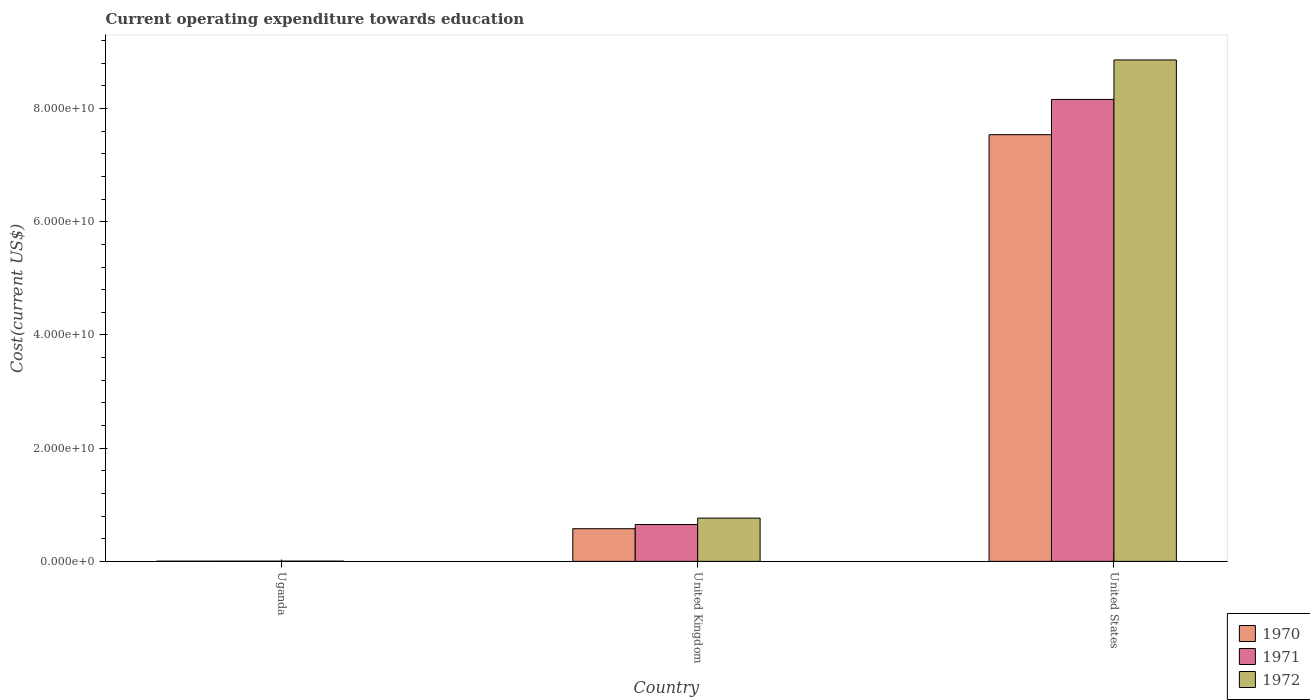How many different coloured bars are there?
Ensure brevity in your answer.  3. Are the number of bars per tick equal to the number of legend labels?
Ensure brevity in your answer.  Yes. Are the number of bars on each tick of the X-axis equal?
Offer a terse response. Yes. How many bars are there on the 2nd tick from the right?
Your response must be concise. 3. What is the label of the 2nd group of bars from the left?
Offer a terse response. United Kingdom. What is the expenditure towards education in 1970 in United States?
Give a very brief answer. 7.54e+1. Across all countries, what is the maximum expenditure towards education in 1972?
Keep it short and to the point. 8.86e+1. Across all countries, what is the minimum expenditure towards education in 1972?
Your answer should be compact. 4.35e+07. In which country was the expenditure towards education in 1970 minimum?
Offer a very short reply. Uganda. What is the total expenditure towards education in 1971 in the graph?
Your answer should be compact. 8.82e+1. What is the difference between the expenditure towards education in 1970 in United Kingdom and that in United States?
Ensure brevity in your answer.  -6.96e+1. What is the difference between the expenditure towards education in 1971 in United States and the expenditure towards education in 1970 in Uganda?
Give a very brief answer. 8.16e+1. What is the average expenditure towards education in 1971 per country?
Your answer should be very brief. 2.94e+1. What is the difference between the expenditure towards education of/in 1970 and expenditure towards education of/in 1971 in United Kingdom?
Your response must be concise. -7.43e+08. What is the ratio of the expenditure towards education in 1972 in Uganda to that in United States?
Make the answer very short. 0. Is the difference between the expenditure towards education in 1970 in United Kingdom and United States greater than the difference between the expenditure towards education in 1971 in United Kingdom and United States?
Offer a very short reply. Yes. What is the difference between the highest and the second highest expenditure towards education in 1971?
Give a very brief answer. 7.51e+1. What is the difference between the highest and the lowest expenditure towards education in 1972?
Your answer should be compact. 8.85e+1. What does the 1st bar from the left in Uganda represents?
Your answer should be very brief. 1970. How many bars are there?
Ensure brevity in your answer.  9. Are all the bars in the graph horizontal?
Your answer should be compact. No. How many countries are there in the graph?
Keep it short and to the point. 3. What is the difference between two consecutive major ticks on the Y-axis?
Your answer should be very brief. 2.00e+1. Does the graph contain any zero values?
Your answer should be very brief. No. Where does the legend appear in the graph?
Provide a short and direct response. Bottom right. How many legend labels are there?
Your answer should be compact. 3. How are the legend labels stacked?
Your response must be concise. Vertical. What is the title of the graph?
Provide a short and direct response. Current operating expenditure towards education. What is the label or title of the Y-axis?
Your answer should be very brief. Cost(current US$). What is the Cost(current US$) in 1970 in Uganda?
Provide a short and direct response. 3.36e+07. What is the Cost(current US$) of 1971 in Uganda?
Ensure brevity in your answer.  3.77e+07. What is the Cost(current US$) of 1972 in Uganda?
Ensure brevity in your answer.  4.35e+07. What is the Cost(current US$) in 1970 in United Kingdom?
Ensure brevity in your answer.  5.77e+09. What is the Cost(current US$) in 1971 in United Kingdom?
Give a very brief answer. 6.51e+09. What is the Cost(current US$) of 1972 in United Kingdom?
Your response must be concise. 7.64e+09. What is the Cost(current US$) of 1970 in United States?
Provide a succinct answer. 7.54e+1. What is the Cost(current US$) of 1971 in United States?
Your answer should be compact. 8.16e+1. What is the Cost(current US$) in 1972 in United States?
Provide a succinct answer. 8.86e+1. Across all countries, what is the maximum Cost(current US$) of 1970?
Ensure brevity in your answer.  7.54e+1. Across all countries, what is the maximum Cost(current US$) in 1971?
Your answer should be very brief. 8.16e+1. Across all countries, what is the maximum Cost(current US$) in 1972?
Provide a succinct answer. 8.86e+1. Across all countries, what is the minimum Cost(current US$) of 1970?
Make the answer very short. 3.36e+07. Across all countries, what is the minimum Cost(current US$) in 1971?
Offer a very short reply. 3.77e+07. Across all countries, what is the minimum Cost(current US$) in 1972?
Your answer should be compact. 4.35e+07. What is the total Cost(current US$) in 1970 in the graph?
Provide a succinct answer. 8.12e+1. What is the total Cost(current US$) in 1971 in the graph?
Your response must be concise. 8.82e+1. What is the total Cost(current US$) in 1972 in the graph?
Offer a very short reply. 9.63e+1. What is the difference between the Cost(current US$) of 1970 in Uganda and that in United Kingdom?
Offer a very short reply. -5.74e+09. What is the difference between the Cost(current US$) of 1971 in Uganda and that in United Kingdom?
Your response must be concise. -6.48e+09. What is the difference between the Cost(current US$) of 1972 in Uganda and that in United Kingdom?
Provide a succinct answer. -7.60e+09. What is the difference between the Cost(current US$) in 1970 in Uganda and that in United States?
Make the answer very short. -7.53e+1. What is the difference between the Cost(current US$) in 1971 in Uganda and that in United States?
Keep it short and to the point. -8.16e+1. What is the difference between the Cost(current US$) of 1972 in Uganda and that in United States?
Keep it short and to the point. -8.85e+1. What is the difference between the Cost(current US$) of 1970 in United Kingdom and that in United States?
Ensure brevity in your answer.  -6.96e+1. What is the difference between the Cost(current US$) in 1971 in United Kingdom and that in United States?
Give a very brief answer. -7.51e+1. What is the difference between the Cost(current US$) in 1972 in United Kingdom and that in United States?
Make the answer very short. -8.09e+1. What is the difference between the Cost(current US$) in 1970 in Uganda and the Cost(current US$) in 1971 in United Kingdom?
Your answer should be compact. -6.48e+09. What is the difference between the Cost(current US$) in 1970 in Uganda and the Cost(current US$) in 1972 in United Kingdom?
Your answer should be compact. -7.61e+09. What is the difference between the Cost(current US$) of 1971 in Uganda and the Cost(current US$) of 1972 in United Kingdom?
Your response must be concise. -7.60e+09. What is the difference between the Cost(current US$) in 1970 in Uganda and the Cost(current US$) in 1971 in United States?
Make the answer very short. -8.16e+1. What is the difference between the Cost(current US$) of 1970 in Uganda and the Cost(current US$) of 1972 in United States?
Make the answer very short. -8.86e+1. What is the difference between the Cost(current US$) of 1971 in Uganda and the Cost(current US$) of 1972 in United States?
Make the answer very short. -8.86e+1. What is the difference between the Cost(current US$) of 1970 in United Kingdom and the Cost(current US$) of 1971 in United States?
Offer a very short reply. -7.58e+1. What is the difference between the Cost(current US$) of 1970 in United Kingdom and the Cost(current US$) of 1972 in United States?
Keep it short and to the point. -8.28e+1. What is the difference between the Cost(current US$) in 1971 in United Kingdom and the Cost(current US$) in 1972 in United States?
Your answer should be compact. -8.21e+1. What is the average Cost(current US$) in 1970 per country?
Provide a short and direct response. 2.71e+1. What is the average Cost(current US$) in 1971 per country?
Your answer should be very brief. 2.94e+1. What is the average Cost(current US$) in 1972 per country?
Your response must be concise. 3.21e+1. What is the difference between the Cost(current US$) in 1970 and Cost(current US$) in 1971 in Uganda?
Provide a succinct answer. -4.06e+06. What is the difference between the Cost(current US$) of 1970 and Cost(current US$) of 1972 in Uganda?
Offer a very short reply. -9.89e+06. What is the difference between the Cost(current US$) in 1971 and Cost(current US$) in 1972 in Uganda?
Give a very brief answer. -5.83e+06. What is the difference between the Cost(current US$) in 1970 and Cost(current US$) in 1971 in United Kingdom?
Offer a terse response. -7.43e+08. What is the difference between the Cost(current US$) of 1970 and Cost(current US$) of 1972 in United Kingdom?
Provide a succinct answer. -1.87e+09. What is the difference between the Cost(current US$) in 1971 and Cost(current US$) in 1972 in United Kingdom?
Give a very brief answer. -1.13e+09. What is the difference between the Cost(current US$) in 1970 and Cost(current US$) in 1971 in United States?
Your response must be concise. -6.23e+09. What is the difference between the Cost(current US$) in 1970 and Cost(current US$) in 1972 in United States?
Ensure brevity in your answer.  -1.32e+1. What is the difference between the Cost(current US$) of 1971 and Cost(current US$) of 1972 in United States?
Make the answer very short. -6.98e+09. What is the ratio of the Cost(current US$) of 1970 in Uganda to that in United Kingdom?
Provide a succinct answer. 0.01. What is the ratio of the Cost(current US$) in 1971 in Uganda to that in United Kingdom?
Offer a very short reply. 0.01. What is the ratio of the Cost(current US$) of 1972 in Uganda to that in United Kingdom?
Keep it short and to the point. 0.01. What is the ratio of the Cost(current US$) in 1970 in Uganda to that in United States?
Your answer should be very brief. 0. What is the ratio of the Cost(current US$) in 1970 in United Kingdom to that in United States?
Your response must be concise. 0.08. What is the ratio of the Cost(current US$) in 1971 in United Kingdom to that in United States?
Your answer should be compact. 0.08. What is the ratio of the Cost(current US$) in 1972 in United Kingdom to that in United States?
Make the answer very short. 0.09. What is the difference between the highest and the second highest Cost(current US$) in 1970?
Keep it short and to the point. 6.96e+1. What is the difference between the highest and the second highest Cost(current US$) of 1971?
Provide a short and direct response. 7.51e+1. What is the difference between the highest and the second highest Cost(current US$) in 1972?
Offer a terse response. 8.09e+1. What is the difference between the highest and the lowest Cost(current US$) in 1970?
Give a very brief answer. 7.53e+1. What is the difference between the highest and the lowest Cost(current US$) of 1971?
Your answer should be very brief. 8.16e+1. What is the difference between the highest and the lowest Cost(current US$) in 1972?
Ensure brevity in your answer.  8.85e+1. 